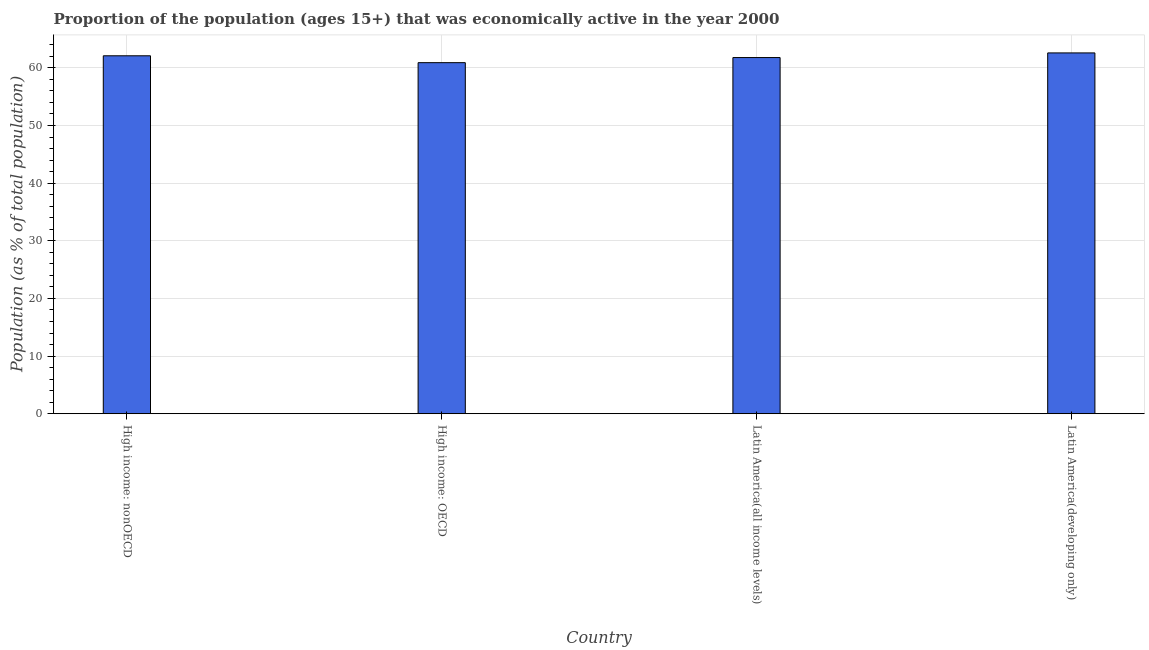What is the title of the graph?
Offer a terse response. Proportion of the population (ages 15+) that was economically active in the year 2000. What is the label or title of the X-axis?
Your response must be concise. Country. What is the label or title of the Y-axis?
Your answer should be compact. Population (as % of total population). What is the percentage of economically active population in High income: OECD?
Provide a short and direct response. 60.9. Across all countries, what is the maximum percentage of economically active population?
Provide a succinct answer. 62.59. Across all countries, what is the minimum percentage of economically active population?
Offer a terse response. 60.9. In which country was the percentage of economically active population maximum?
Your answer should be compact. Latin America(developing only). In which country was the percentage of economically active population minimum?
Offer a very short reply. High income: OECD. What is the sum of the percentage of economically active population?
Offer a terse response. 247.39. What is the difference between the percentage of economically active population in High income: nonOECD and Latin America(all income levels)?
Offer a very short reply. 0.31. What is the average percentage of economically active population per country?
Offer a terse response. 61.85. What is the median percentage of economically active population?
Make the answer very short. 61.94. In how many countries, is the percentage of economically active population greater than 22 %?
Offer a terse response. 4. What is the ratio of the percentage of economically active population in High income: OECD to that in High income: nonOECD?
Offer a terse response. 0.98. Is the difference between the percentage of economically active population in High income: nonOECD and Latin America(all income levels) greater than the difference between any two countries?
Make the answer very short. No. What is the difference between the highest and the second highest percentage of economically active population?
Give a very brief answer. 0.5. Is the sum of the percentage of economically active population in High income: nonOECD and Latin America(all income levels) greater than the maximum percentage of economically active population across all countries?
Your answer should be very brief. Yes. What is the difference between the highest and the lowest percentage of economically active population?
Make the answer very short. 1.69. In how many countries, is the percentage of economically active population greater than the average percentage of economically active population taken over all countries?
Provide a succinct answer. 2. Are all the bars in the graph horizontal?
Provide a succinct answer. No. What is the Population (as % of total population) of High income: nonOECD?
Ensure brevity in your answer.  62.1. What is the Population (as % of total population) of High income: OECD?
Provide a succinct answer. 60.9. What is the Population (as % of total population) of Latin America(all income levels)?
Make the answer very short. 61.79. What is the Population (as % of total population) in Latin America(developing only)?
Your answer should be very brief. 62.59. What is the difference between the Population (as % of total population) in High income: nonOECD and High income: OECD?
Offer a terse response. 1.19. What is the difference between the Population (as % of total population) in High income: nonOECD and Latin America(all income levels)?
Ensure brevity in your answer.  0.31. What is the difference between the Population (as % of total population) in High income: nonOECD and Latin America(developing only)?
Keep it short and to the point. -0.5. What is the difference between the Population (as % of total population) in High income: OECD and Latin America(all income levels)?
Your response must be concise. -0.89. What is the difference between the Population (as % of total population) in High income: OECD and Latin America(developing only)?
Provide a short and direct response. -1.69. What is the difference between the Population (as % of total population) in Latin America(all income levels) and Latin America(developing only)?
Keep it short and to the point. -0.8. What is the ratio of the Population (as % of total population) in High income: nonOECD to that in Latin America(developing only)?
Offer a terse response. 0.99. What is the ratio of the Population (as % of total population) in High income: OECD to that in Latin America(developing only)?
Keep it short and to the point. 0.97. What is the ratio of the Population (as % of total population) in Latin America(all income levels) to that in Latin America(developing only)?
Provide a succinct answer. 0.99. 